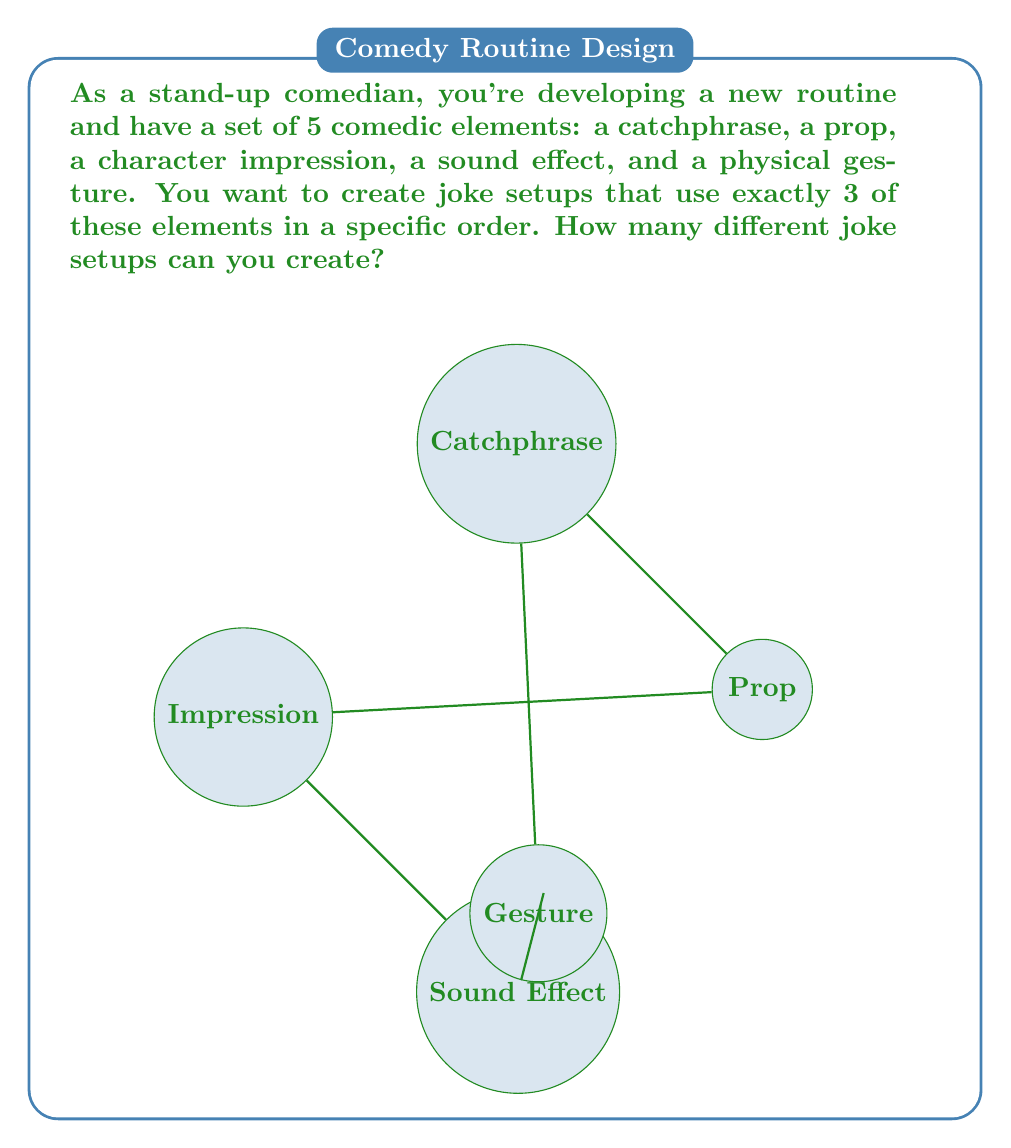Solve this math problem. Let's approach this step-by-step:

1) First, we need to choose 3 elements out of the 5 available. This is a combination problem.

2) The number of ways to choose 3 elements out of 5 is given by the combination formula:

   $$\binom{5}{3} = \frac{5!}{3!(5-3)!} = \frac{5!}{3!2!} = 10$$

3) However, this only gives us the number of ways to select 3 elements. We also need to consider the order of these elements in our setup, as the question specifies "in a specific order".

4) For each selection of 3 elements, we need to arrange them in all possible orders. This is a permutation of 3 elements.

5) The number of permutations of 3 elements is:

   $$3! = 3 \times 2 \times 1 = 6$$

6) By the multiplication principle, the total number of joke setups is the product of the number of ways to choose 3 elements and the number of ways to order these 3 elements:

   $$10 \times 6 = 60$$

Therefore, you can create 60 different joke setups.
Answer: $60$ 